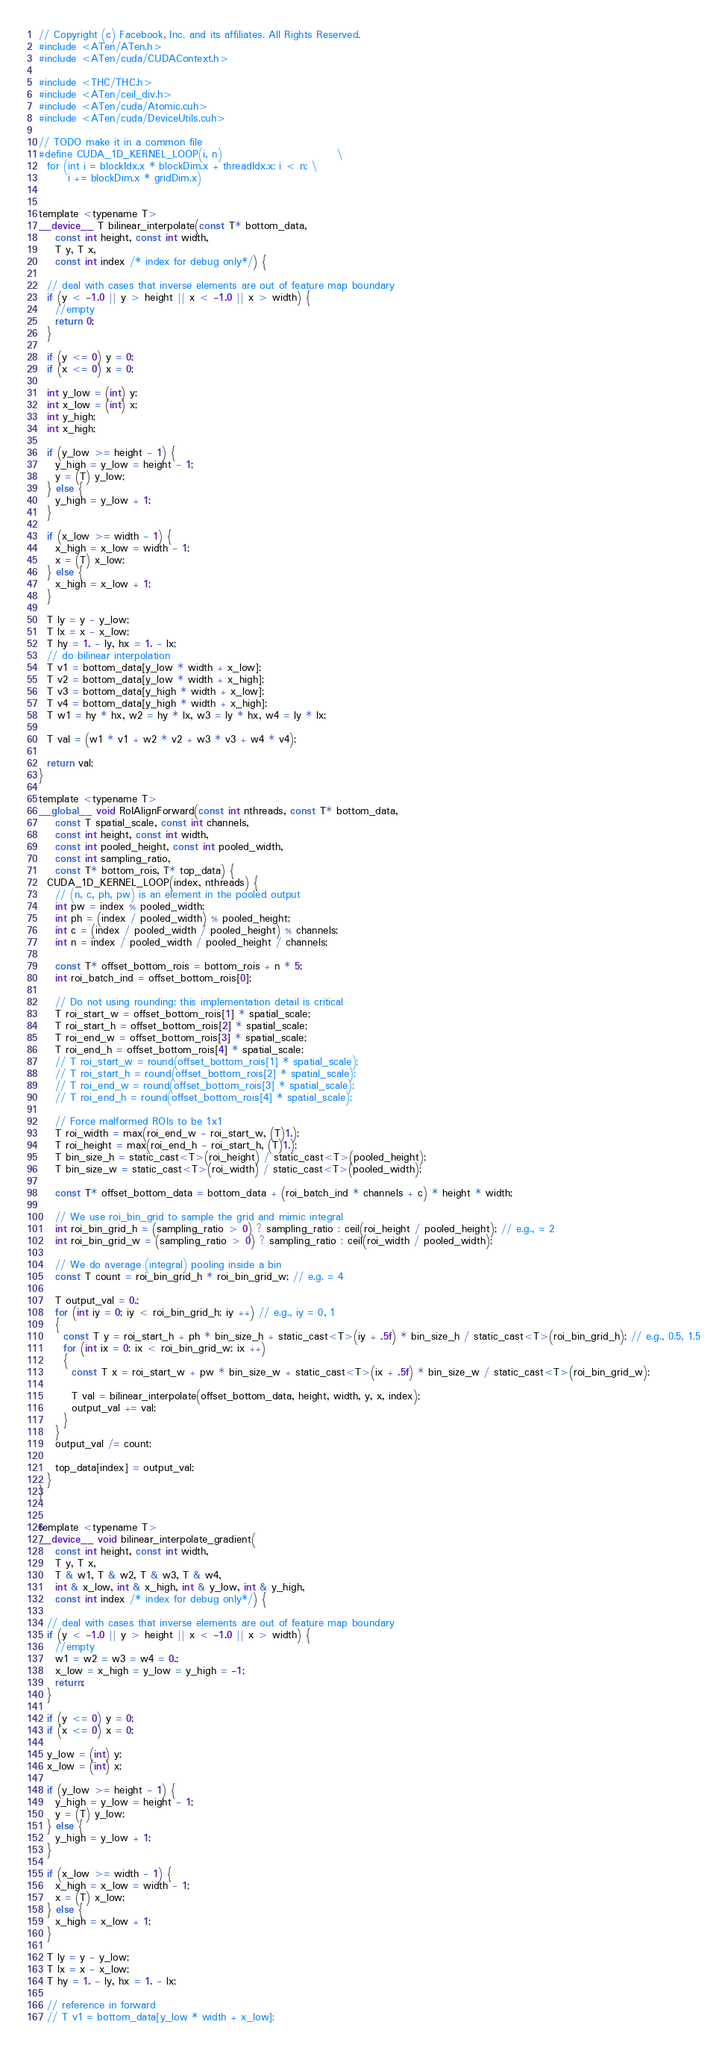<code> <loc_0><loc_0><loc_500><loc_500><_Cuda_>// Copyright (c) Facebook, Inc. and its affiliates. All Rights Reserved.
#include <ATen/ATen.h>
#include <ATen/cuda/CUDAContext.h>

#include <THC/THC.h>
#include <ATen/ceil_div.h>
#include <ATen/cuda/Atomic.cuh>
#include <ATen/cuda/DeviceUtils.cuh>

// TODO make it in a common file
#define CUDA_1D_KERNEL_LOOP(i, n)                            \
  for (int i = blockIdx.x * blockDim.x + threadIdx.x; i < n; \
       i += blockDim.x * gridDim.x)


template <typename T>
__device__ T bilinear_interpolate(const T* bottom_data,
    const int height, const int width,
    T y, T x,
    const int index /* index for debug only*/) {

  // deal with cases that inverse elements are out of feature map boundary
  if (y < -1.0 || y > height || x < -1.0 || x > width) {
    //empty
    return 0;
  }

  if (y <= 0) y = 0;
  if (x <= 0) x = 0;

  int y_low = (int) y;
  int x_low = (int) x;
  int y_high;
  int x_high;

  if (y_low >= height - 1) {
    y_high = y_low = height - 1;
    y = (T) y_low;
  } else {
    y_high = y_low + 1;
  }

  if (x_low >= width - 1) {
    x_high = x_low = width - 1;
    x = (T) x_low;
  } else {
    x_high = x_low + 1;
  }

  T ly = y - y_low;
  T lx = x - x_low;
  T hy = 1. - ly, hx = 1. - lx;
  // do bilinear interpolation
  T v1 = bottom_data[y_low * width + x_low];
  T v2 = bottom_data[y_low * width + x_high];
  T v3 = bottom_data[y_high * width + x_low];
  T v4 = bottom_data[y_high * width + x_high];
  T w1 = hy * hx, w2 = hy * lx, w3 = ly * hx, w4 = ly * lx;

  T val = (w1 * v1 + w2 * v2 + w3 * v3 + w4 * v4);

  return val;
}

template <typename T>
__global__ void RoIAlignForward(const int nthreads, const T* bottom_data,
    const T spatial_scale, const int channels,
    const int height, const int width,
    const int pooled_height, const int pooled_width,
    const int sampling_ratio,
    const T* bottom_rois, T* top_data) {
  CUDA_1D_KERNEL_LOOP(index, nthreads) {
    // (n, c, ph, pw) is an element in the pooled output
    int pw = index % pooled_width;
    int ph = (index / pooled_width) % pooled_height;
    int c = (index / pooled_width / pooled_height) % channels;
    int n = index / pooled_width / pooled_height / channels;

    const T* offset_bottom_rois = bottom_rois + n * 5;
    int roi_batch_ind = offset_bottom_rois[0];

    // Do not using rounding; this implementation detail is critical
    T roi_start_w = offset_bottom_rois[1] * spatial_scale;
    T roi_start_h = offset_bottom_rois[2] * spatial_scale;
    T roi_end_w = offset_bottom_rois[3] * spatial_scale;
    T roi_end_h = offset_bottom_rois[4] * spatial_scale;
    // T roi_start_w = round(offset_bottom_rois[1] * spatial_scale);
    // T roi_start_h = round(offset_bottom_rois[2] * spatial_scale);
    // T roi_end_w = round(offset_bottom_rois[3] * spatial_scale);
    // T roi_end_h = round(offset_bottom_rois[4] * spatial_scale);

    // Force malformed ROIs to be 1x1
    T roi_width = max(roi_end_w - roi_start_w, (T)1.);
    T roi_height = max(roi_end_h - roi_start_h, (T)1.);
    T bin_size_h = static_cast<T>(roi_height) / static_cast<T>(pooled_height);
    T bin_size_w = static_cast<T>(roi_width) / static_cast<T>(pooled_width);

    const T* offset_bottom_data = bottom_data + (roi_batch_ind * channels + c) * height * width;

    // We use roi_bin_grid to sample the grid and mimic integral
    int roi_bin_grid_h = (sampling_ratio > 0) ? sampling_ratio : ceil(roi_height / pooled_height); // e.g., = 2
    int roi_bin_grid_w = (sampling_ratio > 0) ? sampling_ratio : ceil(roi_width / pooled_width);

    // We do average (integral) pooling inside a bin
    const T count = roi_bin_grid_h * roi_bin_grid_w; // e.g. = 4

    T output_val = 0.;
    for (int iy = 0; iy < roi_bin_grid_h; iy ++) // e.g., iy = 0, 1
    {
      const T y = roi_start_h + ph * bin_size_h + static_cast<T>(iy + .5f) * bin_size_h / static_cast<T>(roi_bin_grid_h); // e.g., 0.5, 1.5
      for (int ix = 0; ix < roi_bin_grid_w; ix ++)
      {
        const T x = roi_start_w + pw * bin_size_w + static_cast<T>(ix + .5f) * bin_size_w / static_cast<T>(roi_bin_grid_w);

        T val = bilinear_interpolate(offset_bottom_data, height, width, y, x, index);
        output_val += val;
      }
    }
    output_val /= count;

    top_data[index] = output_val;
  }
}


template <typename T>
__device__ void bilinear_interpolate_gradient(
    const int height, const int width,
    T y, T x,
    T & w1, T & w2, T & w3, T & w4,
    int & x_low, int & x_high, int & y_low, int & y_high,
    const int index /* index for debug only*/) {

  // deal with cases that inverse elements are out of feature map boundary
  if (y < -1.0 || y > height || x < -1.0 || x > width) {
    //empty
    w1 = w2 = w3 = w4 = 0.;
    x_low = x_high = y_low = y_high = -1;
    return;
  }

  if (y <= 0) y = 0;
  if (x <= 0) x = 0;

  y_low = (int) y;
  x_low = (int) x;

  if (y_low >= height - 1) {
    y_high = y_low = height - 1;
    y = (T) y_low;
  } else {
    y_high = y_low + 1;
  }

  if (x_low >= width - 1) {
    x_high = x_low = width - 1;
    x = (T) x_low;
  } else {
    x_high = x_low + 1;
  }

  T ly = y - y_low;
  T lx = x - x_low;
  T hy = 1. - ly, hx = 1. - lx;

  // reference in forward
  // T v1 = bottom_data[y_low * width + x_low];</code> 